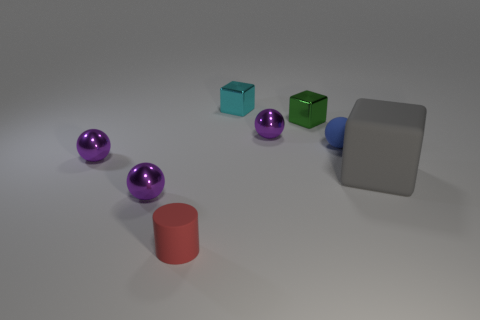There is a rubber cube right of the green block; what size is it?
Give a very brief answer. Large. Are there fewer gray rubber objects than metallic spheres?
Provide a short and direct response. Yes. Are the red object and the gray block made of the same material?
Provide a short and direct response. Yes. What is the color of the small thing that is both behind the tiny cylinder and in front of the gray thing?
Offer a terse response. Purple. Are there any purple shiny balls of the same size as the red rubber object?
Keep it short and to the point. Yes. How big is the block in front of the tiny metal cube in front of the tiny cyan cube?
Make the answer very short. Large. Are there fewer large objects to the left of the big gray matte block than gray things?
Your answer should be compact. Yes. How big is the gray block?
Give a very brief answer. Large. What number of metal objects are the same color as the tiny cylinder?
Your answer should be very brief. 0. There is a tiny rubber thing that is in front of the small purple shiny sphere that is in front of the big rubber object; are there any metallic things to the right of it?
Your answer should be very brief. Yes. 